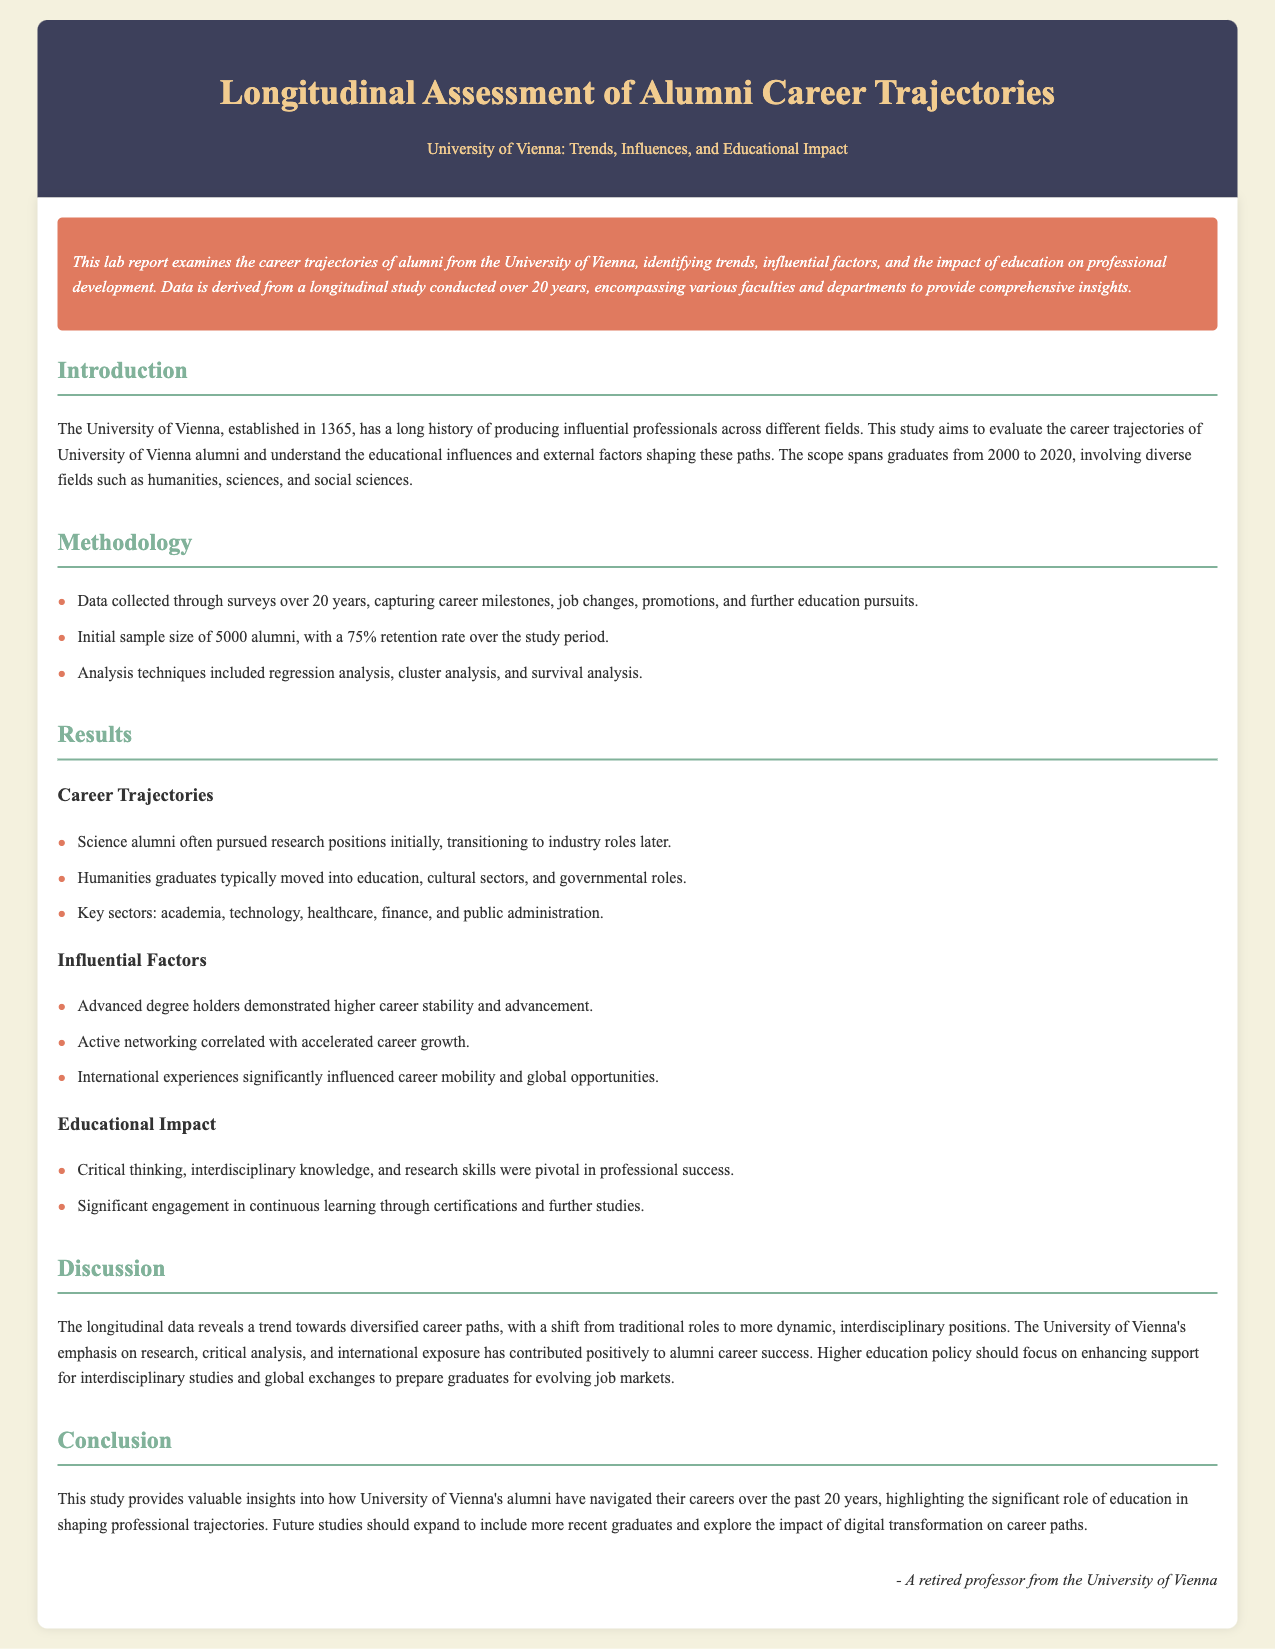What is the main focus of the lab report? The report examines the career trajectories of University of Vienna alumni, identifying trends, influential factors, and educational impact.
Answer: career trajectories of University of Vienna alumni How many years does the study cover? The study spans graduates from 2000 to 2020, thus covering a period of 20 years.
Answer: 20 years What was the initial sample size of alumni surveyed? The report states that the initial sample size of alumni was 5000.
Answer: 5000 What percentage of alumni were retained over the study period? A 75% retention rate was noted for the alumni surveyed throughout the study.
Answer: 75% Which sector did humanities graduates typically move into? Humanities graduates typically moved into education, cultural sectors, and governmental roles.
Answer: education, cultural sectors, and governmental roles What was a key factor that correlated with accelerated career growth? Active networking was identified as a key factor correlating with accelerated career growth.
Answer: Active networking What skills were highlighted as pivotal in professional success? Critical thinking, interdisciplinary knowledge, and research skills were highlighted as pivotal.
Answer: Critical thinking, interdisciplinary knowledge, and research skills What does the report suggest for higher education policy? The report suggests focusing on enhancing support for interdisciplinary studies and global exchanges.
Answer: enhancing support for interdisciplinary studies and global exchanges What is the conclusion of the study regarding alumni careers? The study concludes that education significantly shapes professional trajectories of alumni.
Answer: education significantly shapes professional trajectories 